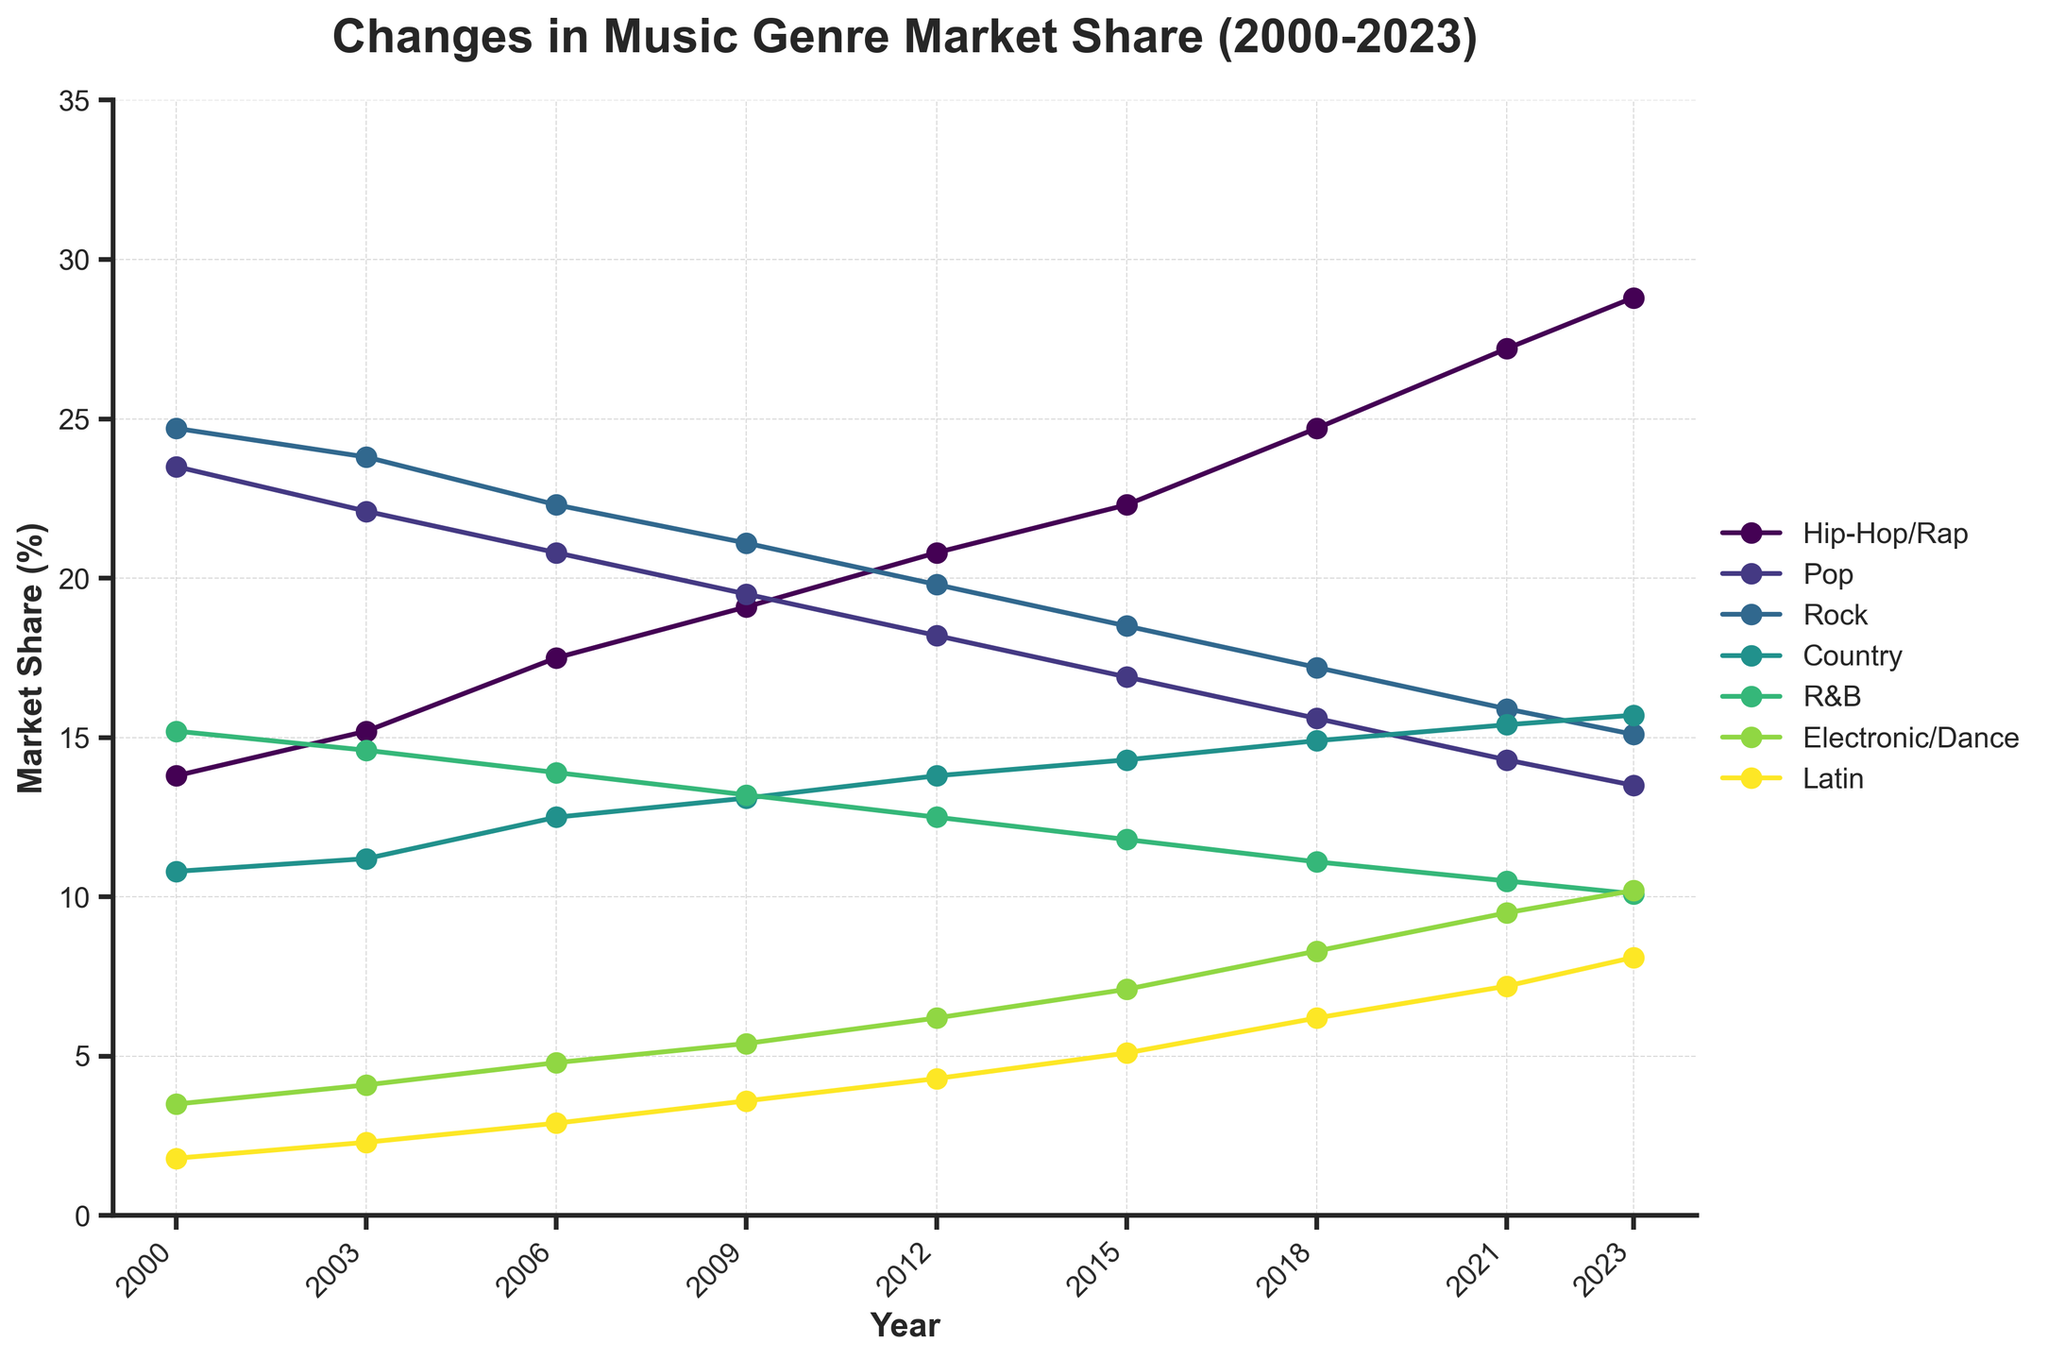What genre showed the most growth in market share from 2000 to 2023? To find the genre with the most growth, we need to calculate the difference in market share from 2000 to 2023 for each genre. Hip-Hop/Rap increased from 13.8% to 28.8% (15% growth), Pop decreased from 23.5% to 13.5% (-10% growth), Rock decreased from 24.7% to 15.1% (-9.6% growth), Country increased from 10.8% to 15.7% (4.9% growth), R&B decreased from 15.2% to 10.1% (-5.1% growth), Electronic/Dance increased from 3.5% to 10.2% (6.7% growth), and Latin increased from 1.8% to 8.1% (6.3% growth). Therefore, Hip-Hop/Rap showed the most growth.
Answer: Hip-Hop/Rap Which genre had the highest market share in 2009? To find the genre with the highest market share in 2009, we need to look at the values for that year. In 2009, Hip-Hop/Rap is at 19.1%, Pop is at 19.5%, Rock is at 21.1%, Country is at 13.1%, R&B is at 13.2%, Electronic/Dance is at 5.4%, and Latin is at 3.6%. Rock has the highest market share at 21.1%.
Answer: Rock How did the market share of Electronic/Dance change from 2000 to 2023? To identify how the market share changed, we subtract the market share in 2000 from the market share in 2023. The market share for Electronic/Dance in 2000 was 3.5% and in 2023 was 10.2%. The change is 10.2% - 3.5% = 6.7%.
Answer: Increased by 6.7% Between which two years did Pop music experience the largest decrease in market share? To determine this, we need to evaluate the differences in Pop market share between consecutive years: 2000-2003 (1.4% decrease), 2003-2006 (1.3% decrease), 2006-2009 (1.3% decrease), 2009-2012 (1.3% decrease), 2012-2015 (1.3% decrease), 2015-2018 (1.3% decrease), 2018-2021 (1.3% decrease), and 2021-2023 (0.8% decrease). The largest decrease happened between 2018 and 2021 where it decreased from 15.6% to 14.3%.
Answer: 2018 to 2021 In which year did Hip-Hop/Rap surpass Pop in terms of market share? To determine when Hip-Hop/Rap surpassed Pop, we compare their market shares for each year. Hip-Hop/Rap surpassed Pop in 2012; in that year, Hip-Hop/Rap had 20.8% and Pop had 18.2%.
Answer: 2012 